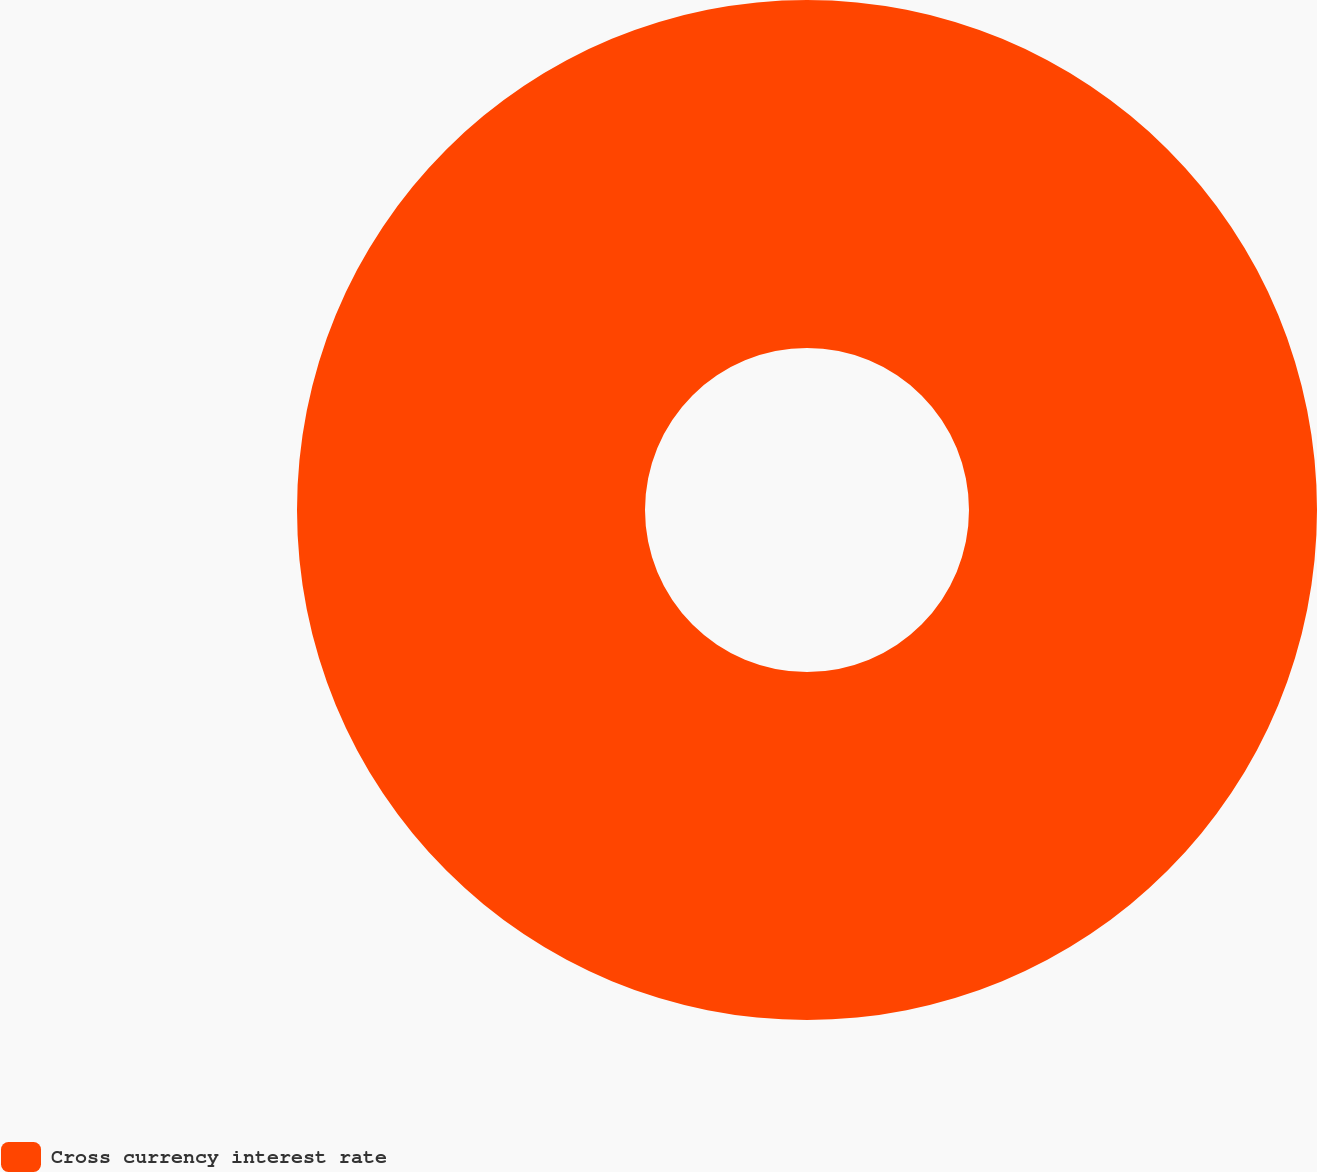Convert chart. <chart><loc_0><loc_0><loc_500><loc_500><pie_chart><fcel>Cross currency interest rate<nl><fcel>100.0%<nl></chart> 